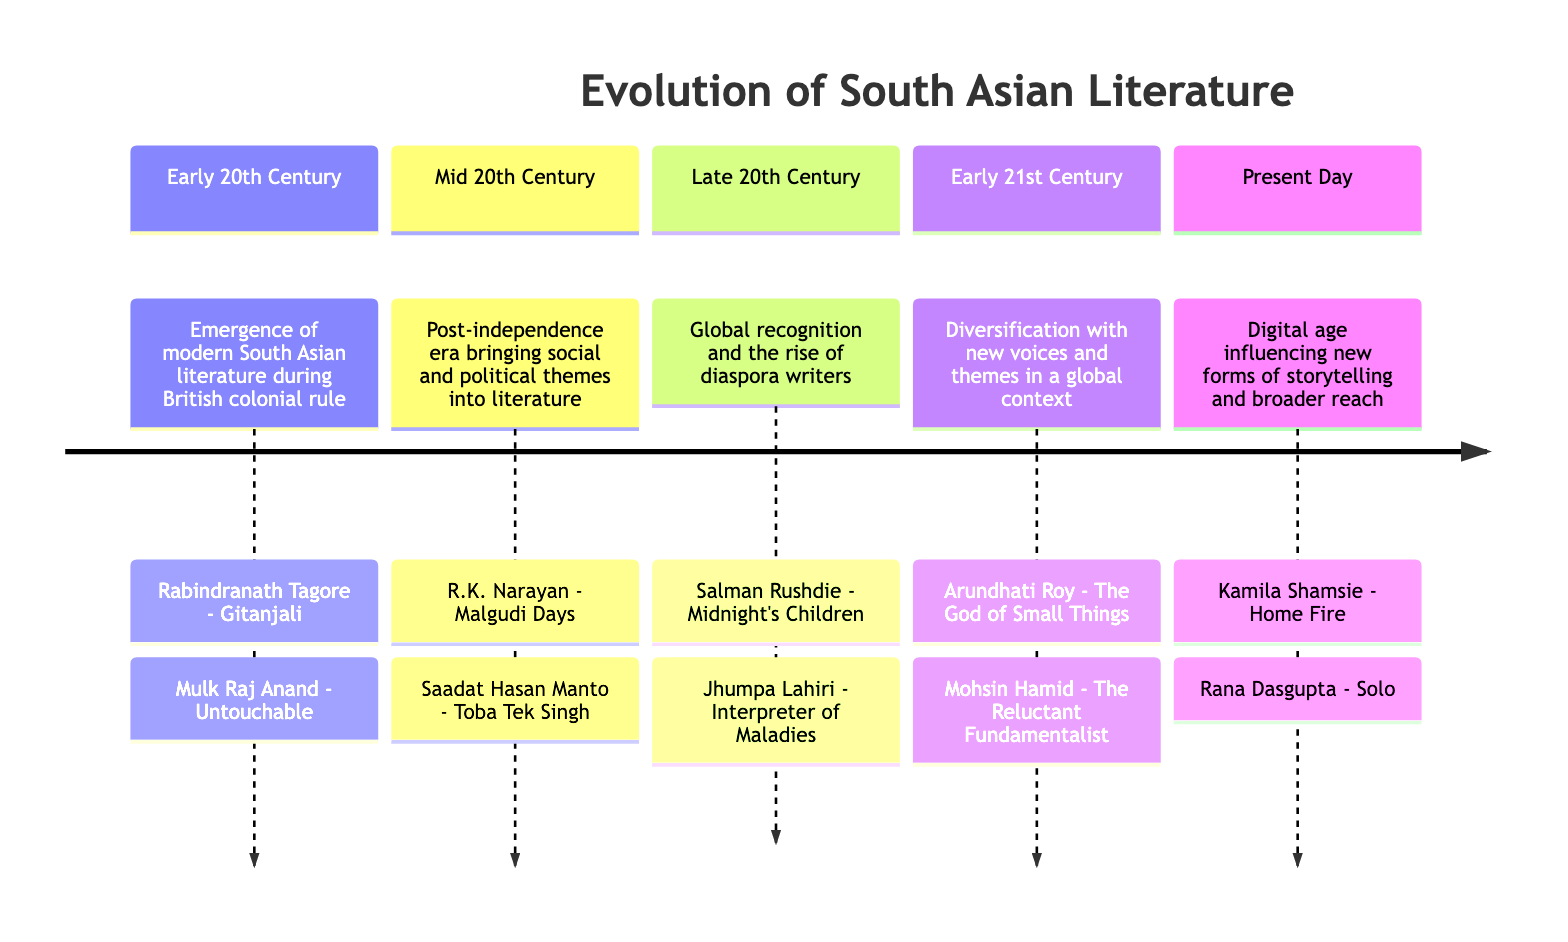What period marked the emergence of modern South Asian literature? The diagram indicates that the "Early 20th Century" is the period marking the emergence of modern South Asian literature during British colonial rule.
Answer: Early 20th Century Who wrote "Gitanjali"? According to the diagram, "Gitanjali" is a notable work by Rabindranath Tagore.
Answer: Rabindranath Tagore Which author is associated with "Toba Tek Singh"? The diagram shows that Saadat Hasan Manto is the author associated with "Toba Tek Singh."
Answer: Saadat Hasan Manto How many key authors are listed for the Late 20th Century? The diagram lists two key authors, Salman Rushdie and Jhumpa Lahiri, for the Late 20th Century.
Answer: 2 Which author is highlighted in the Present Day for their work "Home Fire"? According to the diagram, Kamila Shamsie is highlighted in the Present Day for her work "Home Fire."
Answer: Kamila Shamsie What theme is emphasized in the Mid 20th Century literature? The diagram notes that the Mid 20th Century literature emphasizes social and political themes.
Answer: Social and political themes Which work is associated with Mohsin Hamid? The diagram shows that "The Reluctant Fundamentalist" is the notable work associated with Mohsin Hamid.
Answer: The Reluctant Fundamentalist What is a significant characteristic of the Early 21st Century in South Asian literature? The diagram mentions that the Early 21st Century is characterized by diversification with new voices and themes in a global context.
Answer: Diversification with new voices Who wrote "Interpreter of Maladies"? Jhumpa Lahiri is credited with writing "Interpreter of Maladies" as per the diagram.
Answer: Jhumpa Lahiri 